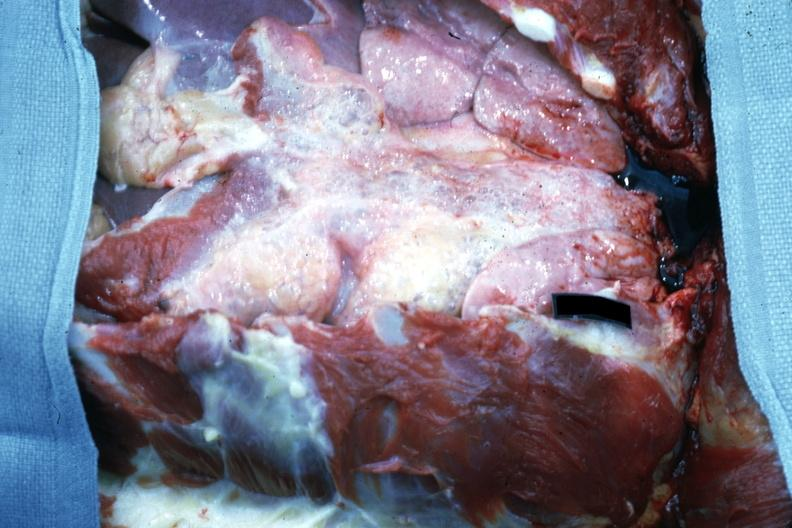what removed easily seen air bubbles?
Answer the question using a single word or phrase. Opened chest with breast plate 